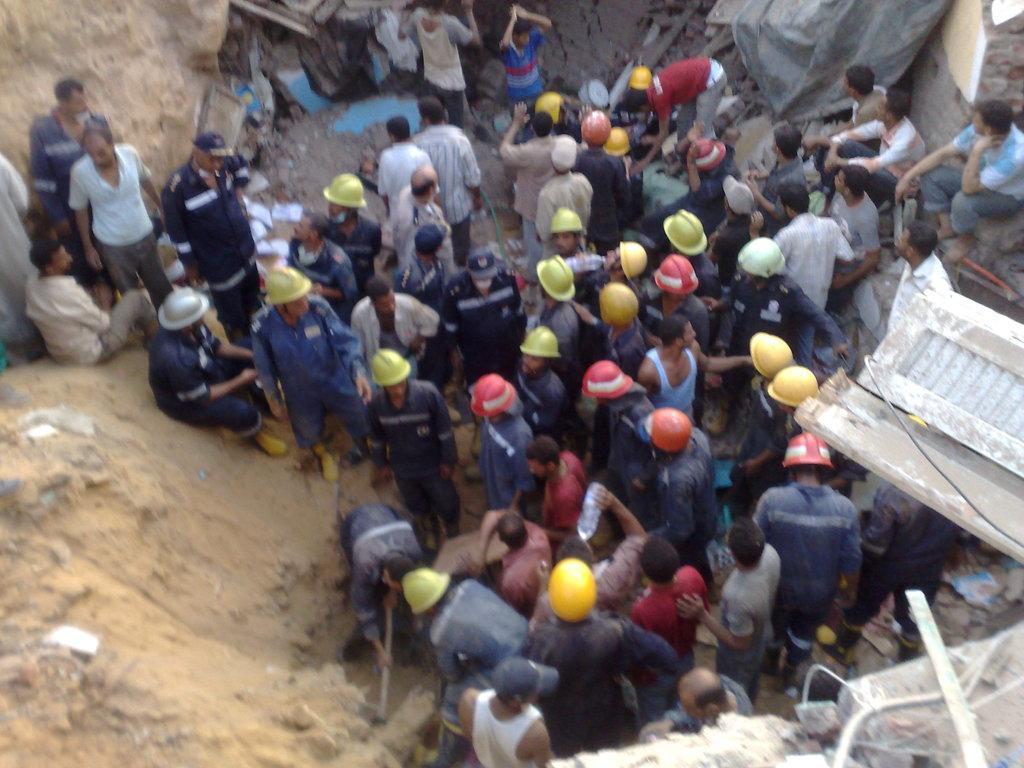How would you summarize this image in a sentence or two? In this image I can see a crowd, mud, rods and a wall. This image is taken near the construction site. 